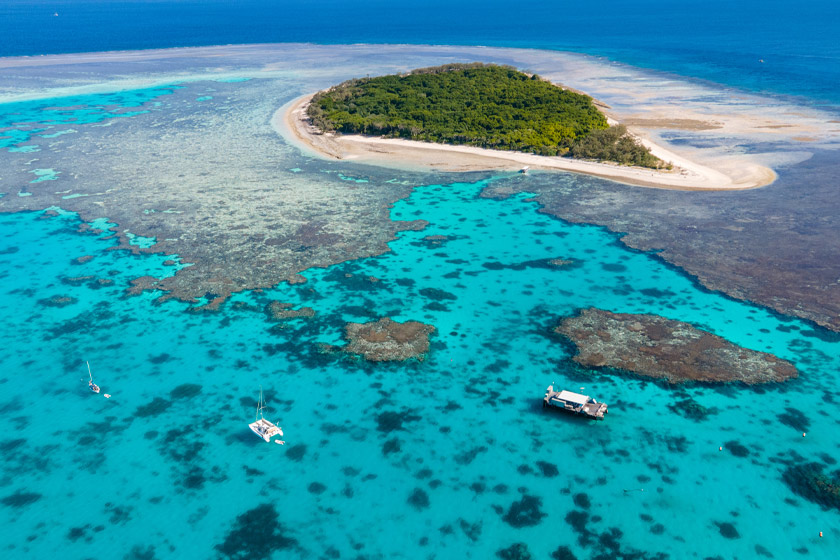Can you describe the main features of this image for me?
 The image captures the breathtaking beauty of the Great Barrier Reef, one of the world's most renowned landmarks located in Australia. From an aerial perspective, the vibrant blue waters of the reef encircle a small island, densely covered with lush green forest. The coral formations, a key feature of the reef, are clearly visible beneath the surface of the water, their intricate patterns creating a stunning contrast against the sandy island and the deep blue sea. Several boats can be seen scattered across the water, likely carrying tourists eager to explore the wonders of the reef. The image beautifully encapsulates the unique ecosystem of the Great Barrier Reef, showcasing its rich biodiversity and the mesmerizing colors that make it a truly remarkable sight. 